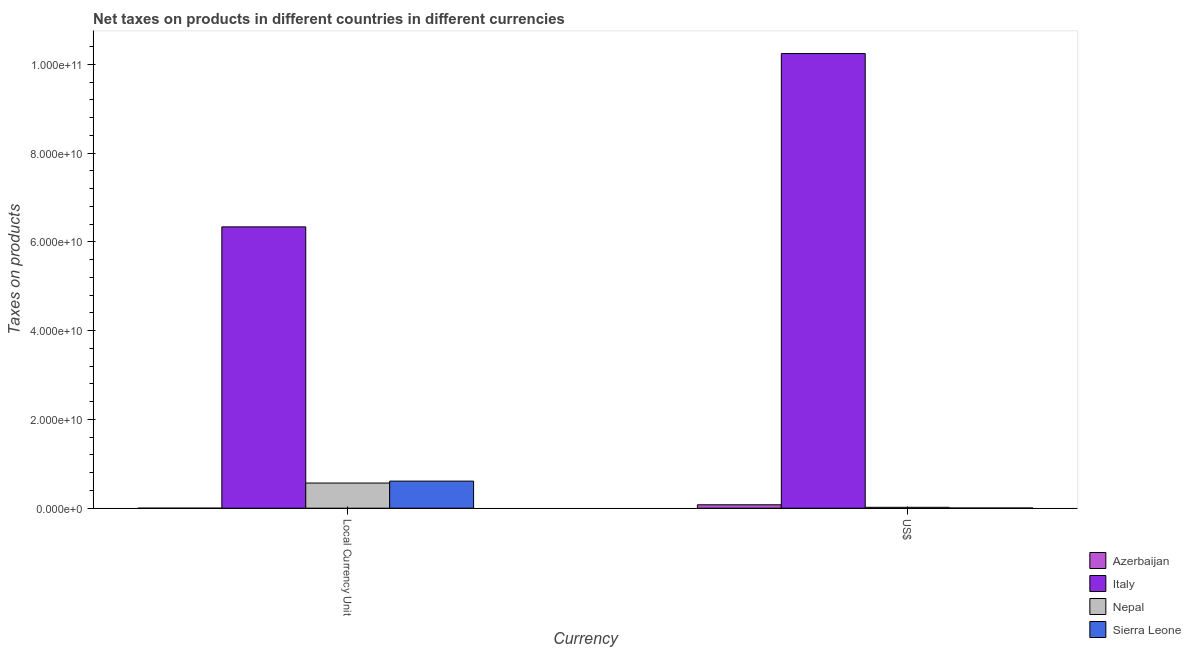Are the number of bars per tick equal to the number of legend labels?
Offer a very short reply. Yes. How many bars are there on the 2nd tick from the left?
Offer a very short reply. 4. What is the label of the 2nd group of bars from the left?
Your answer should be very brief. US$. What is the net taxes in constant 2005 us$ in Sierra Leone?
Keep it short and to the point. 6.10e+09. Across all countries, what is the maximum net taxes in constant 2005 us$?
Your answer should be compact. 6.34e+1. Across all countries, what is the minimum net taxes in us$?
Make the answer very short. 4.03e+07. In which country was the net taxes in constant 2005 us$ maximum?
Offer a very short reply. Italy. In which country was the net taxes in constant 2005 us$ minimum?
Keep it short and to the point. Azerbaijan. What is the total net taxes in us$ in the graph?
Keep it short and to the point. 1.03e+11. What is the difference between the net taxes in us$ in Azerbaijan and that in Nepal?
Give a very brief answer. 5.72e+08. What is the difference between the net taxes in constant 2005 us$ in Sierra Leone and the net taxes in us$ in Azerbaijan?
Offer a very short reply. 5.33e+09. What is the average net taxes in constant 2005 us$ per country?
Your response must be concise. 1.88e+1. What is the difference between the net taxes in constant 2005 us$ and net taxes in us$ in Nepal?
Give a very brief answer. 5.47e+09. What is the ratio of the net taxes in constant 2005 us$ in Nepal to that in Sierra Leone?
Offer a very short reply. 0.93. In how many countries, is the net taxes in us$ greater than the average net taxes in us$ taken over all countries?
Provide a succinct answer. 1. What does the 1st bar from the left in US$ represents?
Your response must be concise. Azerbaijan. What does the 1st bar from the right in Local Currency Unit represents?
Offer a very short reply. Sierra Leone. How many bars are there?
Your answer should be very brief. 8. Are all the bars in the graph horizontal?
Make the answer very short. No. How many countries are there in the graph?
Give a very brief answer. 4. Are the values on the major ticks of Y-axis written in scientific E-notation?
Provide a succinct answer. Yes. Does the graph contain any zero values?
Give a very brief answer. No. Where does the legend appear in the graph?
Your answer should be very brief. Bottom right. How many legend labels are there?
Offer a very short reply. 4. What is the title of the graph?
Your answer should be compact. Net taxes on products in different countries in different currencies. What is the label or title of the X-axis?
Your answer should be very brief. Currency. What is the label or title of the Y-axis?
Provide a short and direct response. Taxes on products. What is the Taxes on products in Azerbaijan in Local Currency Unit?
Make the answer very short. 2.55e+04. What is the Taxes on products of Italy in Local Currency Unit?
Provide a short and direct response. 6.34e+1. What is the Taxes on products in Nepal in Local Currency Unit?
Offer a terse response. 5.67e+09. What is the Taxes on products in Sierra Leone in Local Currency Unit?
Your answer should be compact. 6.10e+09. What is the Taxes on products of Azerbaijan in US$?
Give a very brief answer. 7.70e+08. What is the Taxes on products of Italy in US$?
Ensure brevity in your answer.  1.02e+11. What is the Taxes on products in Nepal in US$?
Keep it short and to the point. 1.99e+08. What is the Taxes on products of Sierra Leone in US$?
Provide a succinct answer. 4.03e+07. Across all Currency, what is the maximum Taxes on products of Azerbaijan?
Your answer should be compact. 7.70e+08. Across all Currency, what is the maximum Taxes on products of Italy?
Give a very brief answer. 1.02e+11. Across all Currency, what is the maximum Taxes on products of Nepal?
Provide a short and direct response. 5.67e+09. Across all Currency, what is the maximum Taxes on products of Sierra Leone?
Provide a succinct answer. 6.10e+09. Across all Currency, what is the minimum Taxes on products in Azerbaijan?
Ensure brevity in your answer.  2.55e+04. Across all Currency, what is the minimum Taxes on products of Italy?
Give a very brief answer. 6.34e+1. Across all Currency, what is the minimum Taxes on products of Nepal?
Keep it short and to the point. 1.99e+08. Across all Currency, what is the minimum Taxes on products in Sierra Leone?
Keep it short and to the point. 4.03e+07. What is the total Taxes on products of Azerbaijan in the graph?
Offer a terse response. 7.70e+08. What is the total Taxes on products of Italy in the graph?
Ensure brevity in your answer.  1.66e+11. What is the total Taxes on products in Nepal in the graph?
Provide a succinct answer. 5.87e+09. What is the total Taxes on products of Sierra Leone in the graph?
Your answer should be very brief. 6.14e+09. What is the difference between the Taxes on products in Azerbaijan in Local Currency Unit and that in US$?
Keep it short and to the point. -7.70e+08. What is the difference between the Taxes on products of Italy in Local Currency Unit and that in US$?
Offer a terse response. -3.91e+1. What is the difference between the Taxes on products of Nepal in Local Currency Unit and that in US$?
Provide a succinct answer. 5.47e+09. What is the difference between the Taxes on products in Sierra Leone in Local Currency Unit and that in US$?
Offer a terse response. 6.06e+09. What is the difference between the Taxes on products in Azerbaijan in Local Currency Unit and the Taxes on products in Italy in US$?
Offer a terse response. -1.02e+11. What is the difference between the Taxes on products in Azerbaijan in Local Currency Unit and the Taxes on products in Nepal in US$?
Make the answer very short. -1.99e+08. What is the difference between the Taxes on products in Azerbaijan in Local Currency Unit and the Taxes on products in Sierra Leone in US$?
Your answer should be compact. -4.03e+07. What is the difference between the Taxes on products in Italy in Local Currency Unit and the Taxes on products in Nepal in US$?
Provide a succinct answer. 6.32e+1. What is the difference between the Taxes on products of Italy in Local Currency Unit and the Taxes on products of Sierra Leone in US$?
Keep it short and to the point. 6.34e+1. What is the difference between the Taxes on products in Nepal in Local Currency Unit and the Taxes on products in Sierra Leone in US$?
Make the answer very short. 5.63e+09. What is the average Taxes on products of Azerbaijan per Currency?
Keep it short and to the point. 3.85e+08. What is the average Taxes on products of Italy per Currency?
Give a very brief answer. 8.29e+1. What is the average Taxes on products in Nepal per Currency?
Offer a very short reply. 2.93e+09. What is the average Taxes on products of Sierra Leone per Currency?
Your response must be concise. 3.07e+09. What is the difference between the Taxes on products of Azerbaijan and Taxes on products of Italy in Local Currency Unit?
Your answer should be compact. -6.34e+1. What is the difference between the Taxes on products of Azerbaijan and Taxes on products of Nepal in Local Currency Unit?
Your response must be concise. -5.67e+09. What is the difference between the Taxes on products of Azerbaijan and Taxes on products of Sierra Leone in Local Currency Unit?
Make the answer very short. -6.10e+09. What is the difference between the Taxes on products in Italy and Taxes on products in Nepal in Local Currency Unit?
Provide a short and direct response. 5.77e+1. What is the difference between the Taxes on products of Italy and Taxes on products of Sierra Leone in Local Currency Unit?
Provide a short and direct response. 5.73e+1. What is the difference between the Taxes on products in Nepal and Taxes on products in Sierra Leone in Local Currency Unit?
Ensure brevity in your answer.  -4.34e+08. What is the difference between the Taxes on products in Azerbaijan and Taxes on products in Italy in US$?
Offer a very short reply. -1.02e+11. What is the difference between the Taxes on products in Azerbaijan and Taxes on products in Nepal in US$?
Your answer should be compact. 5.72e+08. What is the difference between the Taxes on products in Azerbaijan and Taxes on products in Sierra Leone in US$?
Ensure brevity in your answer.  7.30e+08. What is the difference between the Taxes on products in Italy and Taxes on products in Nepal in US$?
Your response must be concise. 1.02e+11. What is the difference between the Taxes on products in Italy and Taxes on products in Sierra Leone in US$?
Your answer should be very brief. 1.02e+11. What is the difference between the Taxes on products in Nepal and Taxes on products in Sierra Leone in US$?
Your answer should be compact. 1.59e+08. What is the ratio of the Taxes on products of Azerbaijan in Local Currency Unit to that in US$?
Offer a very short reply. 0. What is the ratio of the Taxes on products in Italy in Local Currency Unit to that in US$?
Provide a short and direct response. 0.62. What is the ratio of the Taxes on products in Nepal in Local Currency Unit to that in US$?
Keep it short and to the point. 28.51. What is the ratio of the Taxes on products of Sierra Leone in Local Currency Unit to that in US$?
Offer a terse response. 151.45. What is the difference between the highest and the second highest Taxes on products of Azerbaijan?
Ensure brevity in your answer.  7.70e+08. What is the difference between the highest and the second highest Taxes on products in Italy?
Your response must be concise. 3.91e+1. What is the difference between the highest and the second highest Taxes on products in Nepal?
Your response must be concise. 5.47e+09. What is the difference between the highest and the second highest Taxes on products in Sierra Leone?
Keep it short and to the point. 6.06e+09. What is the difference between the highest and the lowest Taxes on products in Azerbaijan?
Ensure brevity in your answer.  7.70e+08. What is the difference between the highest and the lowest Taxes on products of Italy?
Offer a very short reply. 3.91e+1. What is the difference between the highest and the lowest Taxes on products in Nepal?
Keep it short and to the point. 5.47e+09. What is the difference between the highest and the lowest Taxes on products of Sierra Leone?
Your answer should be very brief. 6.06e+09. 